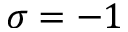Convert formula to latex. <formula><loc_0><loc_0><loc_500><loc_500>\sigma = - 1</formula> 